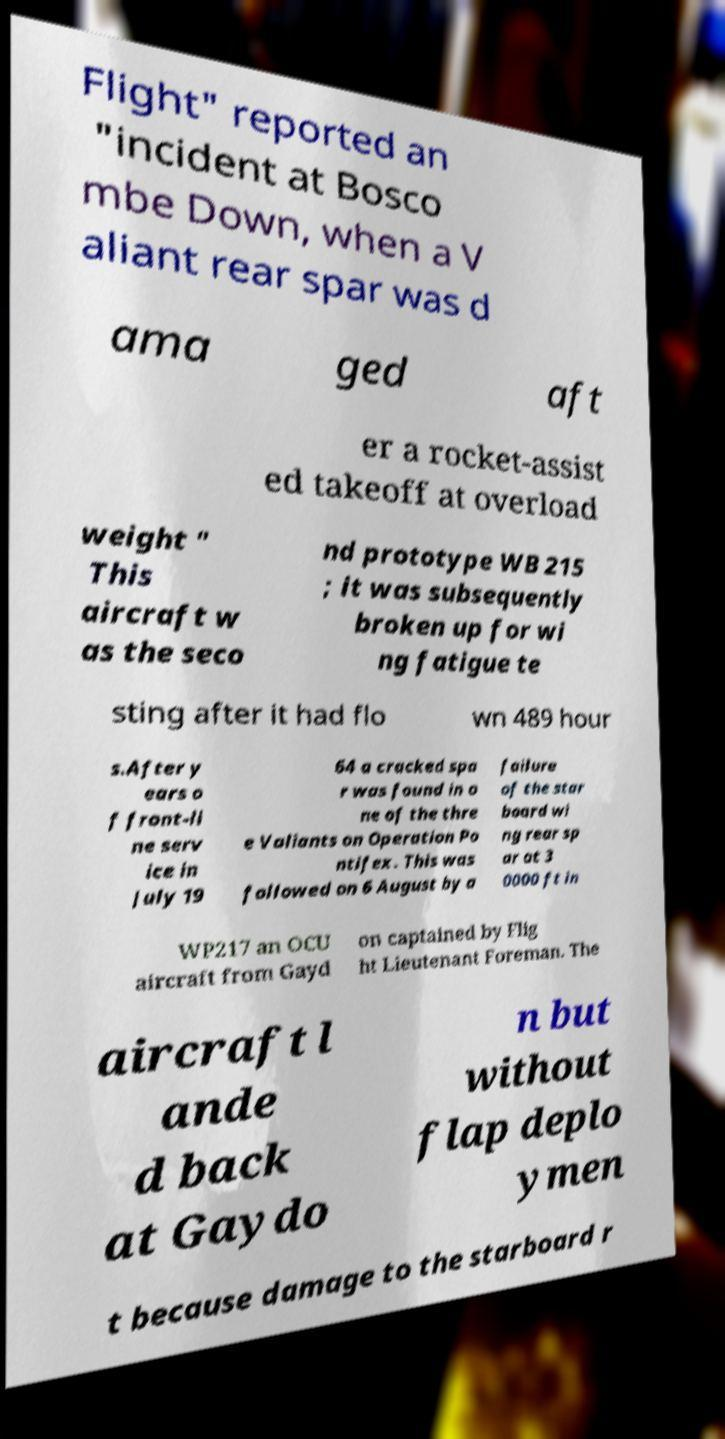Could you extract and type out the text from this image? Flight" reported an "incident at Bosco mbe Down, when a V aliant rear spar was d ama ged aft er a rocket-assist ed takeoff at overload weight " This aircraft w as the seco nd prototype WB 215 ; it was subsequently broken up for wi ng fatigue te sting after it had flo wn 489 hour s.After y ears o f front-li ne serv ice in July 19 64 a cracked spa r was found in o ne of the thre e Valiants on Operation Po ntifex. This was followed on 6 August by a failure of the star board wi ng rear sp ar at 3 0000 ft in WP217 an OCU aircraft from Gayd on captained by Flig ht Lieutenant Foreman. The aircraft l ande d back at Gaydo n but without flap deplo ymen t because damage to the starboard r 